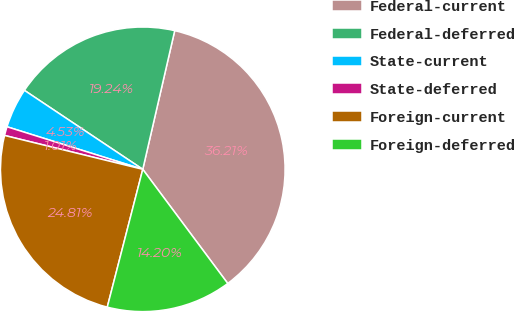Convert chart to OTSL. <chart><loc_0><loc_0><loc_500><loc_500><pie_chart><fcel>Federal-current<fcel>Federal-deferred<fcel>State-current<fcel>State-deferred<fcel>Foreign-current<fcel>Foreign-deferred<nl><fcel>36.21%<fcel>19.24%<fcel>4.53%<fcel>1.01%<fcel>24.81%<fcel>14.2%<nl></chart> 